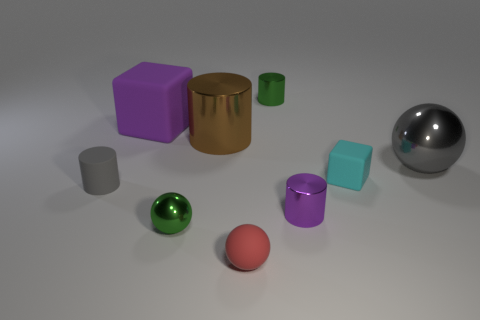Subtract all big cylinders. How many cylinders are left? 3 Add 1 small gray matte cubes. How many objects exist? 10 Subtract all cubes. How many objects are left? 7 Subtract 1 cylinders. How many cylinders are left? 3 Subtract all yellow spheres. Subtract all gray cylinders. How many spheres are left? 3 Subtract all gray things. Subtract all shiny cylinders. How many objects are left? 4 Add 4 large blocks. How many large blocks are left? 5 Add 9 small rubber balls. How many small rubber balls exist? 10 Subtract all purple blocks. How many blocks are left? 1 Subtract 0 cyan spheres. How many objects are left? 9 